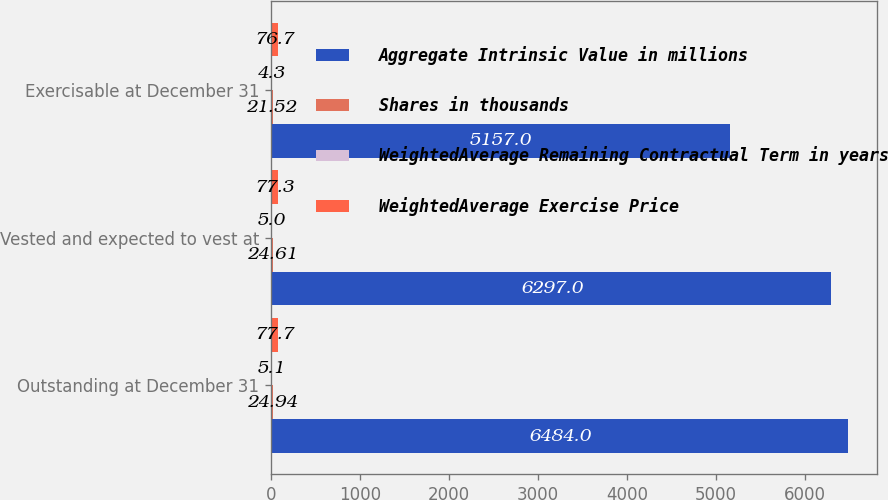Convert chart to OTSL. <chart><loc_0><loc_0><loc_500><loc_500><stacked_bar_chart><ecel><fcel>Outstanding at December 31<fcel>Vested and expected to vest at<fcel>Exercisable at December 31<nl><fcel>Aggregate Intrinsic Value in millions<fcel>6484<fcel>6297<fcel>5157<nl><fcel>Shares in thousands<fcel>24.94<fcel>24.61<fcel>21.52<nl><fcel>WeightedAverage Remaining Contractual Term in years<fcel>5.1<fcel>5<fcel>4.3<nl><fcel>WeightedAverage Exercise Price<fcel>77.7<fcel>77.3<fcel>76.7<nl></chart> 